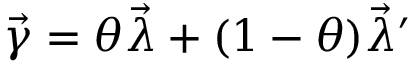<formula> <loc_0><loc_0><loc_500><loc_500>{ \vec { \gamma } } = \theta { \vec { \lambda } } + ( 1 - \theta ) { \vec { \lambda } } ^ { \prime }</formula> 